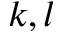Convert formula to latex. <formula><loc_0><loc_0><loc_500><loc_500>k , l</formula> 